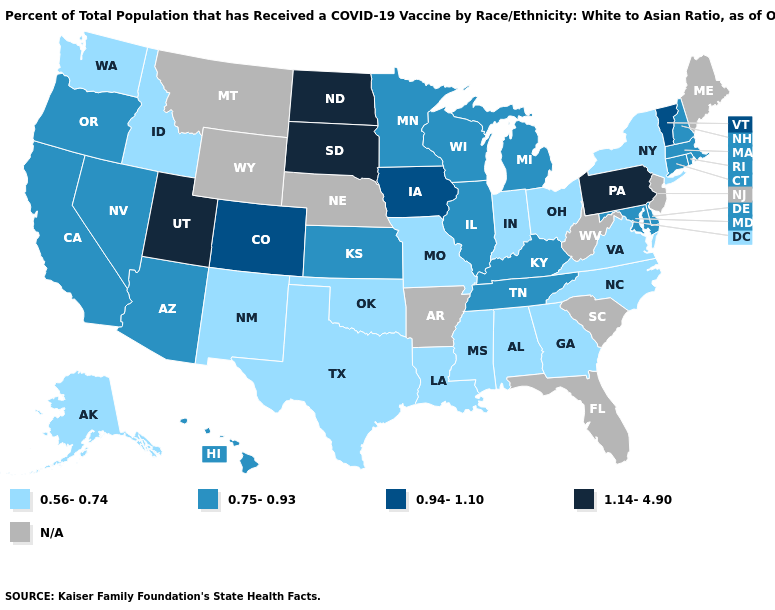How many symbols are there in the legend?
Be succinct. 5. Name the states that have a value in the range N/A?
Give a very brief answer. Arkansas, Florida, Maine, Montana, Nebraska, New Jersey, South Carolina, West Virginia, Wyoming. What is the value of Arizona?
Keep it brief. 0.75-0.93. Among the states that border Virginia , does North Carolina have the lowest value?
Be succinct. Yes. Name the states that have a value in the range N/A?
Quick response, please. Arkansas, Florida, Maine, Montana, Nebraska, New Jersey, South Carolina, West Virginia, Wyoming. Name the states that have a value in the range N/A?
Quick response, please. Arkansas, Florida, Maine, Montana, Nebraska, New Jersey, South Carolina, West Virginia, Wyoming. Name the states that have a value in the range 0.56-0.74?
Give a very brief answer. Alabama, Alaska, Georgia, Idaho, Indiana, Louisiana, Mississippi, Missouri, New Mexico, New York, North Carolina, Ohio, Oklahoma, Texas, Virginia, Washington. Name the states that have a value in the range N/A?
Concise answer only. Arkansas, Florida, Maine, Montana, Nebraska, New Jersey, South Carolina, West Virginia, Wyoming. What is the value of Idaho?
Short answer required. 0.56-0.74. What is the value of West Virginia?
Quick response, please. N/A. What is the value of Colorado?
Give a very brief answer. 0.94-1.10. What is the value of New Mexico?
Write a very short answer. 0.56-0.74. How many symbols are there in the legend?
Write a very short answer. 5. What is the highest value in the West ?
Concise answer only. 1.14-4.90. What is the value of Kansas?
Be succinct. 0.75-0.93. 